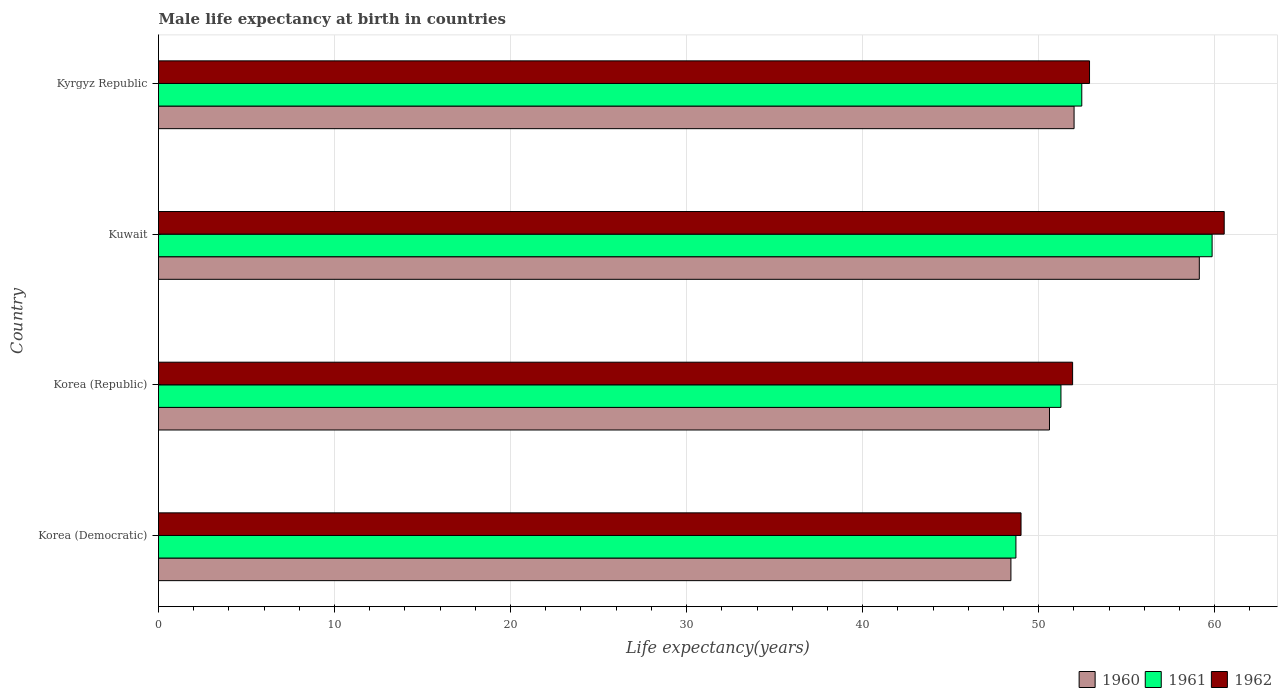How many different coloured bars are there?
Your answer should be compact. 3. Are the number of bars on each tick of the Y-axis equal?
Provide a short and direct response. Yes. How many bars are there on the 4th tick from the top?
Offer a very short reply. 3. What is the label of the 4th group of bars from the top?
Ensure brevity in your answer.  Korea (Democratic). What is the male life expectancy at birth in 1960 in Korea (Republic)?
Offer a very short reply. 50.61. Across all countries, what is the maximum male life expectancy at birth in 1961?
Your answer should be very brief. 59.85. Across all countries, what is the minimum male life expectancy at birth in 1961?
Your response must be concise. 48.71. In which country was the male life expectancy at birth in 1961 maximum?
Ensure brevity in your answer.  Kuwait. In which country was the male life expectancy at birth in 1962 minimum?
Make the answer very short. Korea (Democratic). What is the total male life expectancy at birth in 1961 in the graph?
Make the answer very short. 212.28. What is the difference between the male life expectancy at birth in 1962 in Korea (Democratic) and that in Kuwait?
Provide a short and direct response. -11.54. What is the difference between the male life expectancy at birth in 1962 in Kyrgyz Republic and the male life expectancy at birth in 1961 in Korea (Republic)?
Make the answer very short. 1.62. What is the average male life expectancy at birth in 1962 per country?
Keep it short and to the point. 53.59. What is the difference between the male life expectancy at birth in 1962 and male life expectancy at birth in 1961 in Korea (Democratic)?
Offer a terse response. 0.29. What is the ratio of the male life expectancy at birth in 1962 in Korea (Democratic) to that in Kyrgyz Republic?
Provide a short and direct response. 0.93. Is the difference between the male life expectancy at birth in 1962 in Korea (Republic) and Kyrgyz Republic greater than the difference between the male life expectancy at birth in 1961 in Korea (Republic) and Kyrgyz Republic?
Keep it short and to the point. Yes. What is the difference between the highest and the second highest male life expectancy at birth in 1961?
Provide a succinct answer. 7.4. What is the difference between the highest and the lowest male life expectancy at birth in 1960?
Your answer should be compact. 10.7. In how many countries, is the male life expectancy at birth in 1960 greater than the average male life expectancy at birth in 1960 taken over all countries?
Keep it short and to the point. 1. Is the sum of the male life expectancy at birth in 1961 in Korea (Republic) and Kyrgyz Republic greater than the maximum male life expectancy at birth in 1962 across all countries?
Your response must be concise. Yes. What does the 3rd bar from the bottom in Kyrgyz Republic represents?
Provide a succinct answer. 1962. Is it the case that in every country, the sum of the male life expectancy at birth in 1960 and male life expectancy at birth in 1962 is greater than the male life expectancy at birth in 1961?
Your answer should be very brief. Yes. How many bars are there?
Offer a terse response. 12. Are all the bars in the graph horizontal?
Your answer should be very brief. Yes. How many countries are there in the graph?
Your answer should be very brief. 4. What is the difference between two consecutive major ticks on the X-axis?
Ensure brevity in your answer.  10. Are the values on the major ticks of X-axis written in scientific E-notation?
Your answer should be compact. No. Does the graph contain any zero values?
Provide a succinct answer. No. Does the graph contain grids?
Your answer should be compact. Yes. How are the legend labels stacked?
Keep it short and to the point. Horizontal. What is the title of the graph?
Your answer should be compact. Male life expectancy at birth in countries. Does "1997" appear as one of the legend labels in the graph?
Your response must be concise. No. What is the label or title of the X-axis?
Make the answer very short. Life expectancy(years). What is the label or title of the Y-axis?
Offer a terse response. Country. What is the Life expectancy(years) in 1960 in Korea (Democratic)?
Provide a succinct answer. 48.42. What is the Life expectancy(years) of 1961 in Korea (Democratic)?
Your response must be concise. 48.71. What is the Life expectancy(years) in 1962 in Korea (Democratic)?
Keep it short and to the point. 49. What is the Life expectancy(years) in 1960 in Korea (Republic)?
Offer a very short reply. 50.61. What is the Life expectancy(years) in 1961 in Korea (Republic)?
Offer a terse response. 51.27. What is the Life expectancy(years) in 1962 in Korea (Republic)?
Provide a short and direct response. 51.93. What is the Life expectancy(years) of 1960 in Kuwait?
Your answer should be very brief. 59.13. What is the Life expectancy(years) of 1961 in Kuwait?
Keep it short and to the point. 59.85. What is the Life expectancy(years) of 1962 in Kuwait?
Ensure brevity in your answer.  60.54. What is the Life expectancy(years) of 1960 in Kyrgyz Republic?
Your response must be concise. 52.01. What is the Life expectancy(years) of 1961 in Kyrgyz Republic?
Make the answer very short. 52.45. What is the Life expectancy(years) of 1962 in Kyrgyz Republic?
Your answer should be compact. 52.89. Across all countries, what is the maximum Life expectancy(years) in 1960?
Your answer should be very brief. 59.13. Across all countries, what is the maximum Life expectancy(years) in 1961?
Your response must be concise. 59.85. Across all countries, what is the maximum Life expectancy(years) of 1962?
Give a very brief answer. 60.54. Across all countries, what is the minimum Life expectancy(years) of 1960?
Give a very brief answer. 48.42. Across all countries, what is the minimum Life expectancy(years) in 1961?
Ensure brevity in your answer.  48.71. Across all countries, what is the minimum Life expectancy(years) of 1962?
Provide a short and direct response. 49. What is the total Life expectancy(years) in 1960 in the graph?
Ensure brevity in your answer.  210.18. What is the total Life expectancy(years) in 1961 in the graph?
Offer a very short reply. 212.28. What is the total Life expectancy(years) in 1962 in the graph?
Make the answer very short. 214.35. What is the difference between the Life expectancy(years) of 1960 in Korea (Democratic) and that in Korea (Republic)?
Keep it short and to the point. -2.19. What is the difference between the Life expectancy(years) of 1961 in Korea (Democratic) and that in Korea (Republic)?
Your answer should be compact. -2.56. What is the difference between the Life expectancy(years) of 1962 in Korea (Democratic) and that in Korea (Republic)?
Offer a terse response. -2.93. What is the difference between the Life expectancy(years) in 1960 in Korea (Democratic) and that in Kuwait?
Offer a terse response. -10.7. What is the difference between the Life expectancy(years) of 1961 in Korea (Democratic) and that in Kuwait?
Make the answer very short. -11.14. What is the difference between the Life expectancy(years) in 1962 in Korea (Democratic) and that in Kuwait?
Provide a short and direct response. -11.54. What is the difference between the Life expectancy(years) in 1960 in Korea (Democratic) and that in Kyrgyz Republic?
Make the answer very short. -3.59. What is the difference between the Life expectancy(years) in 1961 in Korea (Democratic) and that in Kyrgyz Republic?
Keep it short and to the point. -3.74. What is the difference between the Life expectancy(years) in 1962 in Korea (Democratic) and that in Kyrgyz Republic?
Your answer should be very brief. -3.89. What is the difference between the Life expectancy(years) of 1960 in Korea (Republic) and that in Kuwait?
Your answer should be compact. -8.51. What is the difference between the Life expectancy(years) in 1961 in Korea (Republic) and that in Kuwait?
Offer a terse response. -8.59. What is the difference between the Life expectancy(years) in 1962 in Korea (Republic) and that in Kuwait?
Your answer should be very brief. -8.61. What is the difference between the Life expectancy(years) of 1960 in Korea (Republic) and that in Kyrgyz Republic?
Your answer should be very brief. -1.4. What is the difference between the Life expectancy(years) of 1961 in Korea (Republic) and that in Kyrgyz Republic?
Give a very brief answer. -1.18. What is the difference between the Life expectancy(years) in 1962 in Korea (Republic) and that in Kyrgyz Republic?
Ensure brevity in your answer.  -0.96. What is the difference between the Life expectancy(years) in 1960 in Kuwait and that in Kyrgyz Republic?
Provide a short and direct response. 7.12. What is the difference between the Life expectancy(years) in 1961 in Kuwait and that in Kyrgyz Republic?
Provide a short and direct response. 7.4. What is the difference between the Life expectancy(years) in 1962 in Kuwait and that in Kyrgyz Republic?
Ensure brevity in your answer.  7.65. What is the difference between the Life expectancy(years) in 1960 in Korea (Democratic) and the Life expectancy(years) in 1961 in Korea (Republic)?
Provide a short and direct response. -2.84. What is the difference between the Life expectancy(years) of 1960 in Korea (Democratic) and the Life expectancy(years) of 1962 in Korea (Republic)?
Offer a very short reply. -3.5. What is the difference between the Life expectancy(years) in 1961 in Korea (Democratic) and the Life expectancy(years) in 1962 in Korea (Republic)?
Give a very brief answer. -3.22. What is the difference between the Life expectancy(years) in 1960 in Korea (Democratic) and the Life expectancy(years) in 1961 in Kuwait?
Your response must be concise. -11.43. What is the difference between the Life expectancy(years) of 1960 in Korea (Democratic) and the Life expectancy(years) of 1962 in Kuwait?
Offer a terse response. -12.12. What is the difference between the Life expectancy(years) in 1961 in Korea (Democratic) and the Life expectancy(years) in 1962 in Kuwait?
Give a very brief answer. -11.83. What is the difference between the Life expectancy(years) in 1960 in Korea (Democratic) and the Life expectancy(years) in 1961 in Kyrgyz Republic?
Keep it short and to the point. -4.03. What is the difference between the Life expectancy(years) in 1960 in Korea (Democratic) and the Life expectancy(years) in 1962 in Kyrgyz Republic?
Ensure brevity in your answer.  -4.46. What is the difference between the Life expectancy(years) of 1961 in Korea (Democratic) and the Life expectancy(years) of 1962 in Kyrgyz Republic?
Ensure brevity in your answer.  -4.18. What is the difference between the Life expectancy(years) of 1960 in Korea (Republic) and the Life expectancy(years) of 1961 in Kuwait?
Provide a short and direct response. -9.24. What is the difference between the Life expectancy(years) of 1960 in Korea (Republic) and the Life expectancy(years) of 1962 in Kuwait?
Offer a terse response. -9.93. What is the difference between the Life expectancy(years) of 1961 in Korea (Republic) and the Life expectancy(years) of 1962 in Kuwait?
Provide a succinct answer. -9.27. What is the difference between the Life expectancy(years) in 1960 in Korea (Republic) and the Life expectancy(years) in 1961 in Kyrgyz Republic?
Your response must be concise. -1.83. What is the difference between the Life expectancy(years) in 1960 in Korea (Republic) and the Life expectancy(years) in 1962 in Kyrgyz Republic?
Keep it short and to the point. -2.27. What is the difference between the Life expectancy(years) of 1961 in Korea (Republic) and the Life expectancy(years) of 1962 in Kyrgyz Republic?
Keep it short and to the point. -1.62. What is the difference between the Life expectancy(years) of 1960 in Kuwait and the Life expectancy(years) of 1961 in Kyrgyz Republic?
Your answer should be compact. 6.68. What is the difference between the Life expectancy(years) in 1960 in Kuwait and the Life expectancy(years) in 1962 in Kyrgyz Republic?
Give a very brief answer. 6.24. What is the difference between the Life expectancy(years) in 1961 in Kuwait and the Life expectancy(years) in 1962 in Kyrgyz Republic?
Provide a succinct answer. 6.96. What is the average Life expectancy(years) in 1960 per country?
Your response must be concise. 52.54. What is the average Life expectancy(years) in 1961 per country?
Ensure brevity in your answer.  53.07. What is the average Life expectancy(years) in 1962 per country?
Make the answer very short. 53.59. What is the difference between the Life expectancy(years) in 1960 and Life expectancy(years) in 1961 in Korea (Democratic)?
Your answer should be very brief. -0.28. What is the difference between the Life expectancy(years) of 1960 and Life expectancy(years) of 1962 in Korea (Democratic)?
Offer a terse response. -0.57. What is the difference between the Life expectancy(years) in 1961 and Life expectancy(years) in 1962 in Korea (Democratic)?
Your response must be concise. -0.29. What is the difference between the Life expectancy(years) in 1960 and Life expectancy(years) in 1961 in Korea (Republic)?
Make the answer very short. -0.65. What is the difference between the Life expectancy(years) of 1960 and Life expectancy(years) of 1962 in Korea (Republic)?
Your response must be concise. -1.31. What is the difference between the Life expectancy(years) in 1961 and Life expectancy(years) in 1962 in Korea (Republic)?
Make the answer very short. -0.66. What is the difference between the Life expectancy(years) in 1960 and Life expectancy(years) in 1961 in Kuwait?
Provide a succinct answer. -0.73. What is the difference between the Life expectancy(years) in 1960 and Life expectancy(years) in 1962 in Kuwait?
Offer a terse response. -1.41. What is the difference between the Life expectancy(years) of 1961 and Life expectancy(years) of 1962 in Kuwait?
Give a very brief answer. -0.69. What is the difference between the Life expectancy(years) of 1960 and Life expectancy(years) of 1961 in Kyrgyz Republic?
Your answer should be very brief. -0.44. What is the difference between the Life expectancy(years) of 1960 and Life expectancy(years) of 1962 in Kyrgyz Republic?
Your response must be concise. -0.88. What is the difference between the Life expectancy(years) in 1961 and Life expectancy(years) in 1962 in Kyrgyz Republic?
Keep it short and to the point. -0.44. What is the ratio of the Life expectancy(years) in 1960 in Korea (Democratic) to that in Korea (Republic)?
Make the answer very short. 0.96. What is the ratio of the Life expectancy(years) of 1961 in Korea (Democratic) to that in Korea (Republic)?
Keep it short and to the point. 0.95. What is the ratio of the Life expectancy(years) in 1962 in Korea (Democratic) to that in Korea (Republic)?
Make the answer very short. 0.94. What is the ratio of the Life expectancy(years) in 1960 in Korea (Democratic) to that in Kuwait?
Your answer should be very brief. 0.82. What is the ratio of the Life expectancy(years) in 1961 in Korea (Democratic) to that in Kuwait?
Provide a succinct answer. 0.81. What is the ratio of the Life expectancy(years) in 1962 in Korea (Democratic) to that in Kuwait?
Your response must be concise. 0.81. What is the ratio of the Life expectancy(years) of 1960 in Korea (Democratic) to that in Kyrgyz Republic?
Make the answer very short. 0.93. What is the ratio of the Life expectancy(years) in 1961 in Korea (Democratic) to that in Kyrgyz Republic?
Your answer should be compact. 0.93. What is the ratio of the Life expectancy(years) of 1962 in Korea (Democratic) to that in Kyrgyz Republic?
Your response must be concise. 0.93. What is the ratio of the Life expectancy(years) in 1960 in Korea (Republic) to that in Kuwait?
Ensure brevity in your answer.  0.86. What is the ratio of the Life expectancy(years) in 1961 in Korea (Republic) to that in Kuwait?
Provide a short and direct response. 0.86. What is the ratio of the Life expectancy(years) of 1962 in Korea (Republic) to that in Kuwait?
Offer a terse response. 0.86. What is the ratio of the Life expectancy(years) in 1960 in Korea (Republic) to that in Kyrgyz Republic?
Ensure brevity in your answer.  0.97. What is the ratio of the Life expectancy(years) of 1961 in Korea (Republic) to that in Kyrgyz Republic?
Provide a short and direct response. 0.98. What is the ratio of the Life expectancy(years) in 1962 in Korea (Republic) to that in Kyrgyz Republic?
Keep it short and to the point. 0.98. What is the ratio of the Life expectancy(years) in 1960 in Kuwait to that in Kyrgyz Republic?
Keep it short and to the point. 1.14. What is the ratio of the Life expectancy(years) in 1961 in Kuwait to that in Kyrgyz Republic?
Keep it short and to the point. 1.14. What is the ratio of the Life expectancy(years) in 1962 in Kuwait to that in Kyrgyz Republic?
Offer a very short reply. 1.14. What is the difference between the highest and the second highest Life expectancy(years) in 1960?
Your answer should be very brief. 7.12. What is the difference between the highest and the second highest Life expectancy(years) in 1961?
Make the answer very short. 7.4. What is the difference between the highest and the second highest Life expectancy(years) of 1962?
Provide a short and direct response. 7.65. What is the difference between the highest and the lowest Life expectancy(years) of 1960?
Your answer should be compact. 10.7. What is the difference between the highest and the lowest Life expectancy(years) of 1961?
Ensure brevity in your answer.  11.14. What is the difference between the highest and the lowest Life expectancy(years) in 1962?
Offer a terse response. 11.54. 